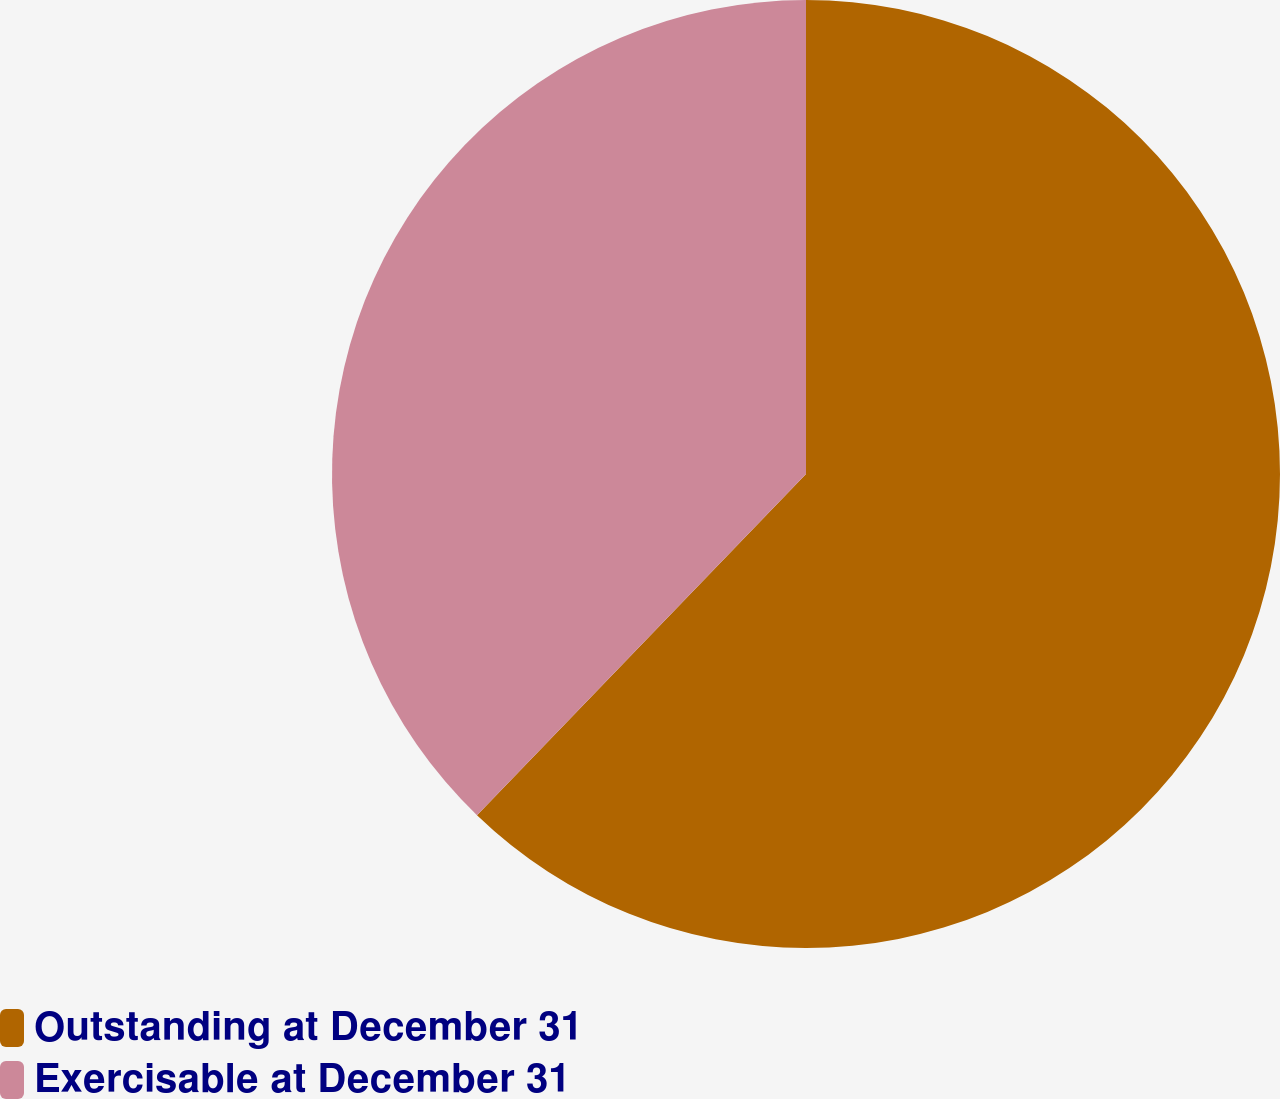Convert chart. <chart><loc_0><loc_0><loc_500><loc_500><pie_chart><fcel>Outstanding at December 31<fcel>Exercisable at December 31<nl><fcel>62.21%<fcel>37.79%<nl></chart> 